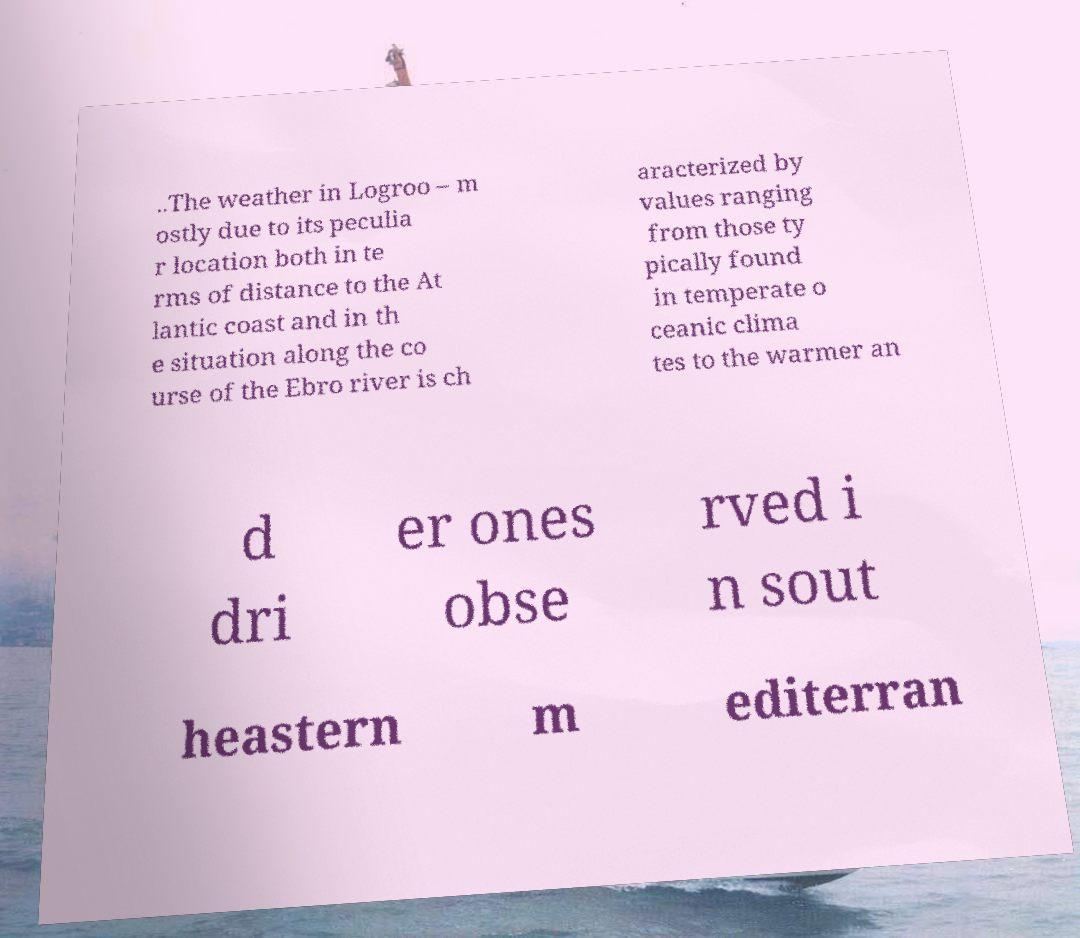I need the written content from this picture converted into text. Can you do that? ..The weather in Logroo – m ostly due to its peculia r location both in te rms of distance to the At lantic coast and in th e situation along the co urse of the Ebro river is ch aracterized by values ranging from those ty pically found in temperate o ceanic clima tes to the warmer an d dri er ones obse rved i n sout heastern m editerran 